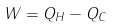Convert formula to latex. <formula><loc_0><loc_0><loc_500><loc_500>W = Q _ { H } - Q _ { C }</formula> 